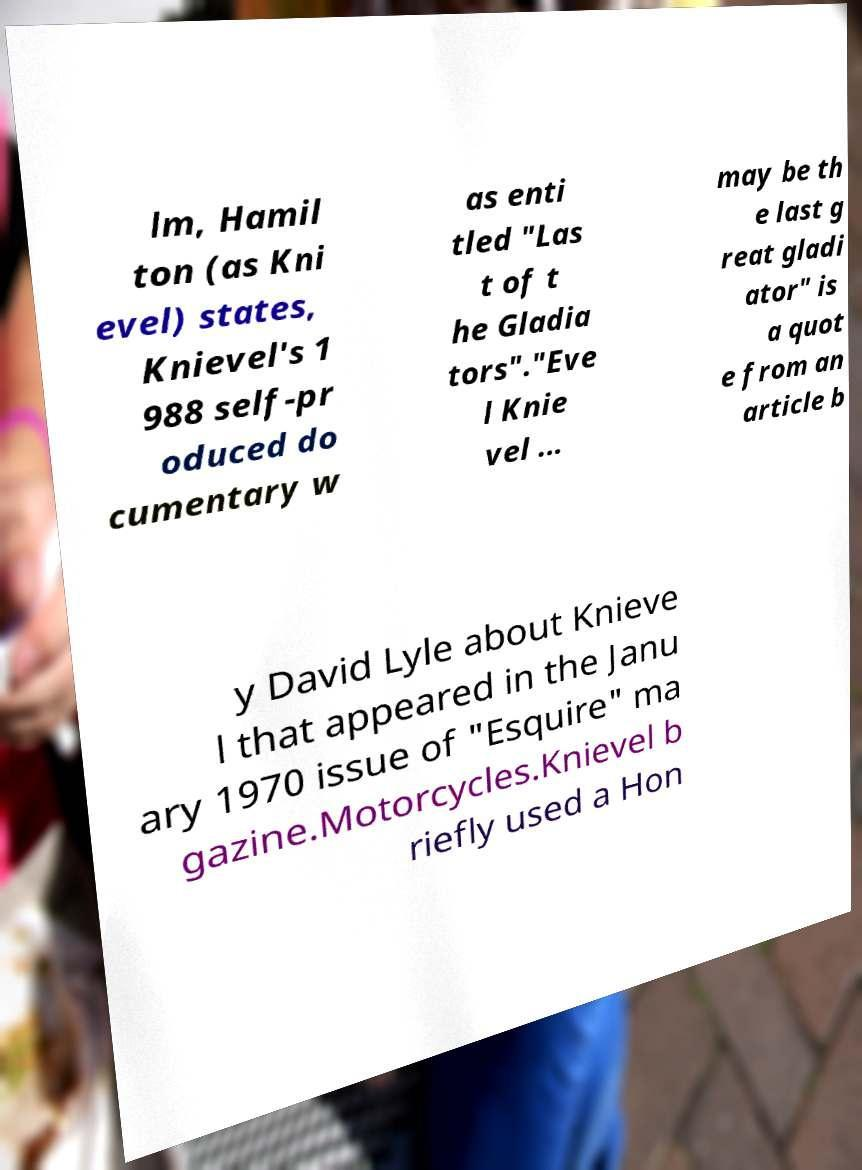Can you read and provide the text displayed in the image?This photo seems to have some interesting text. Can you extract and type it out for me? lm, Hamil ton (as Kni evel) states, Knievel's 1 988 self-pr oduced do cumentary w as enti tled "Las t of t he Gladia tors"."Eve l Knie vel ... may be th e last g reat gladi ator" is a quot e from an article b y David Lyle about Knieve l that appeared in the Janu ary 1970 issue of "Esquire" ma gazine.Motorcycles.Knievel b riefly used a Hon 